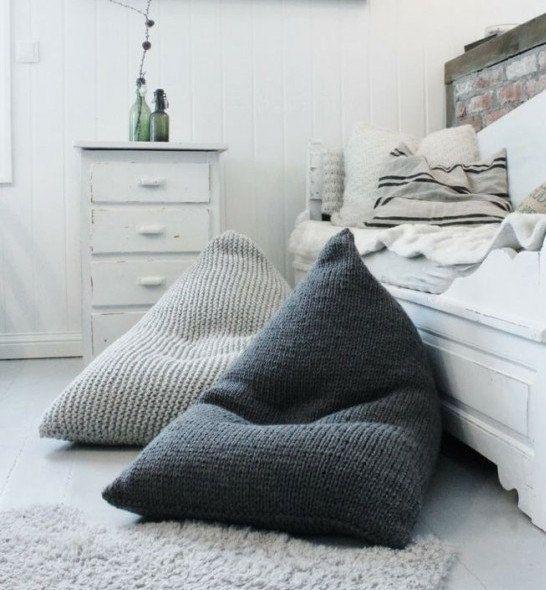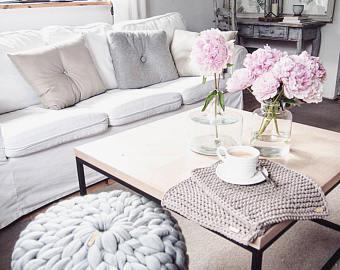The first image is the image on the left, the second image is the image on the right. Evaluate the accuracy of this statement regarding the images: "There are at least 3 crochet pillow stacked on top of each other.". Is it true? Answer yes or no. No. 